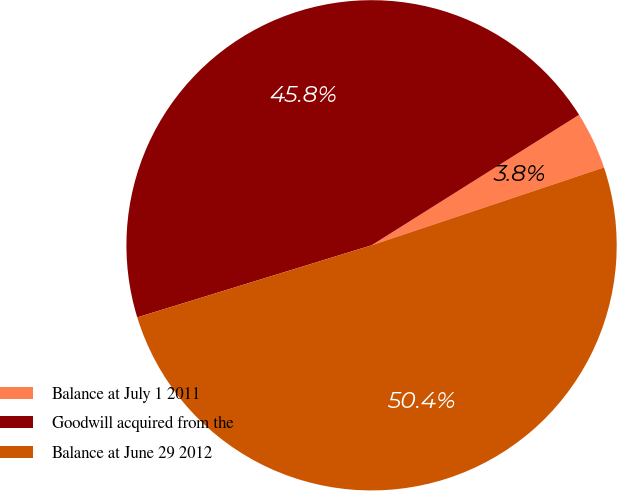Convert chart. <chart><loc_0><loc_0><loc_500><loc_500><pie_chart><fcel>Balance at July 1 2011<fcel>Goodwill acquired from the<fcel>Balance at June 29 2012<nl><fcel>3.79%<fcel>45.81%<fcel>50.39%<nl></chart> 